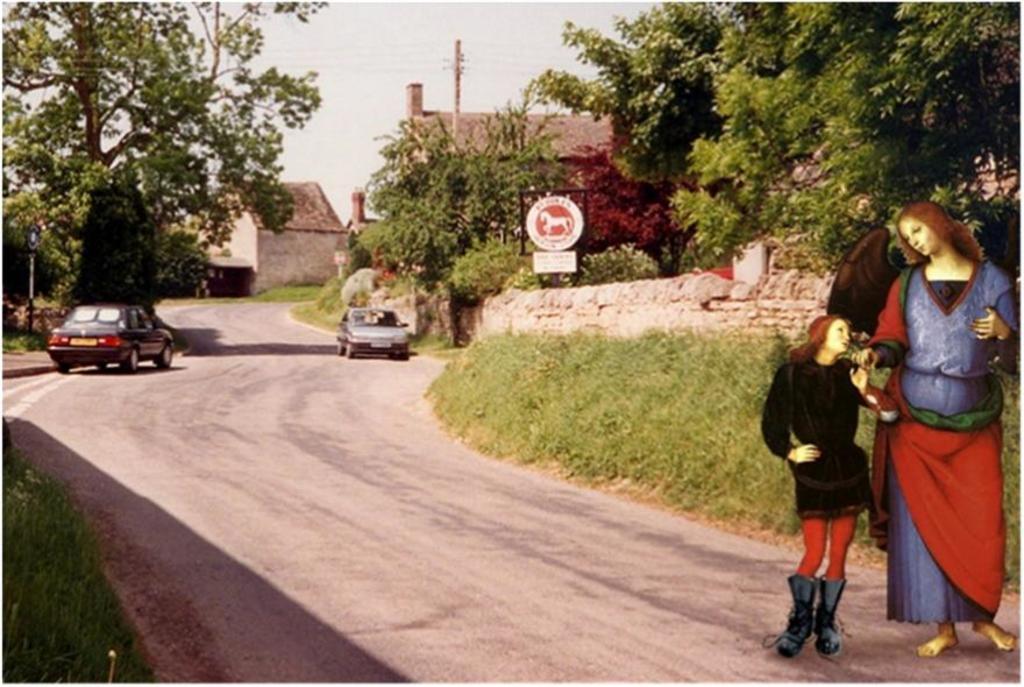How would you summarize this image in a sentence or two? There are vehicles on the road, here there are trees and houses, people are standing, this is sky. 